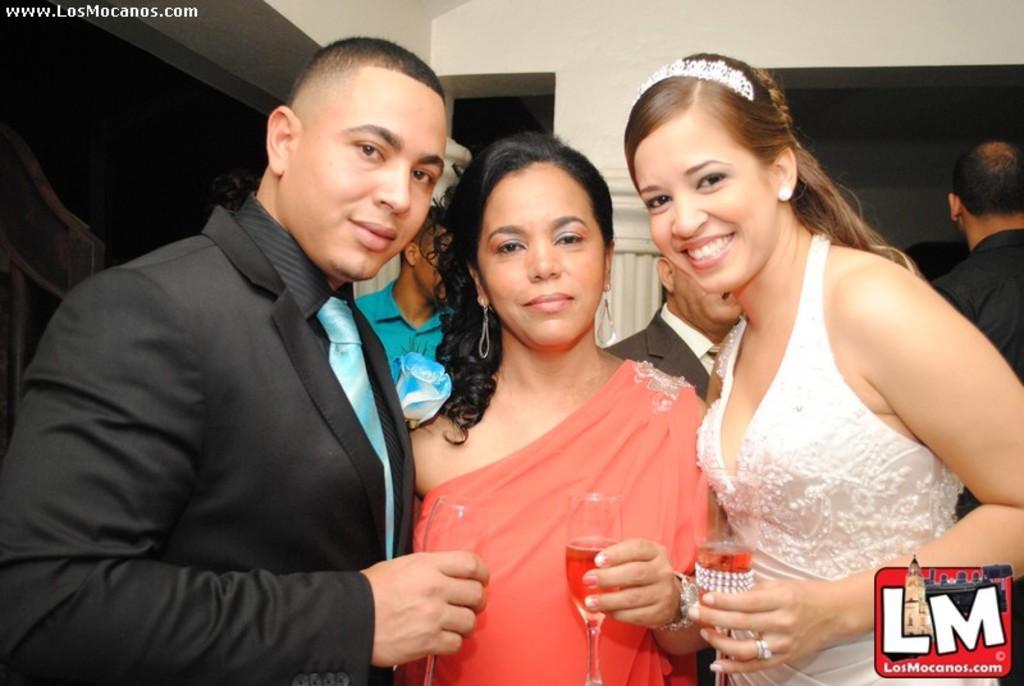Please provide a concise description of this image. In this image I can see few people standing. In front the person is wearing peach color dress and holding the glass. In the background I can see the pillar in cream color. 